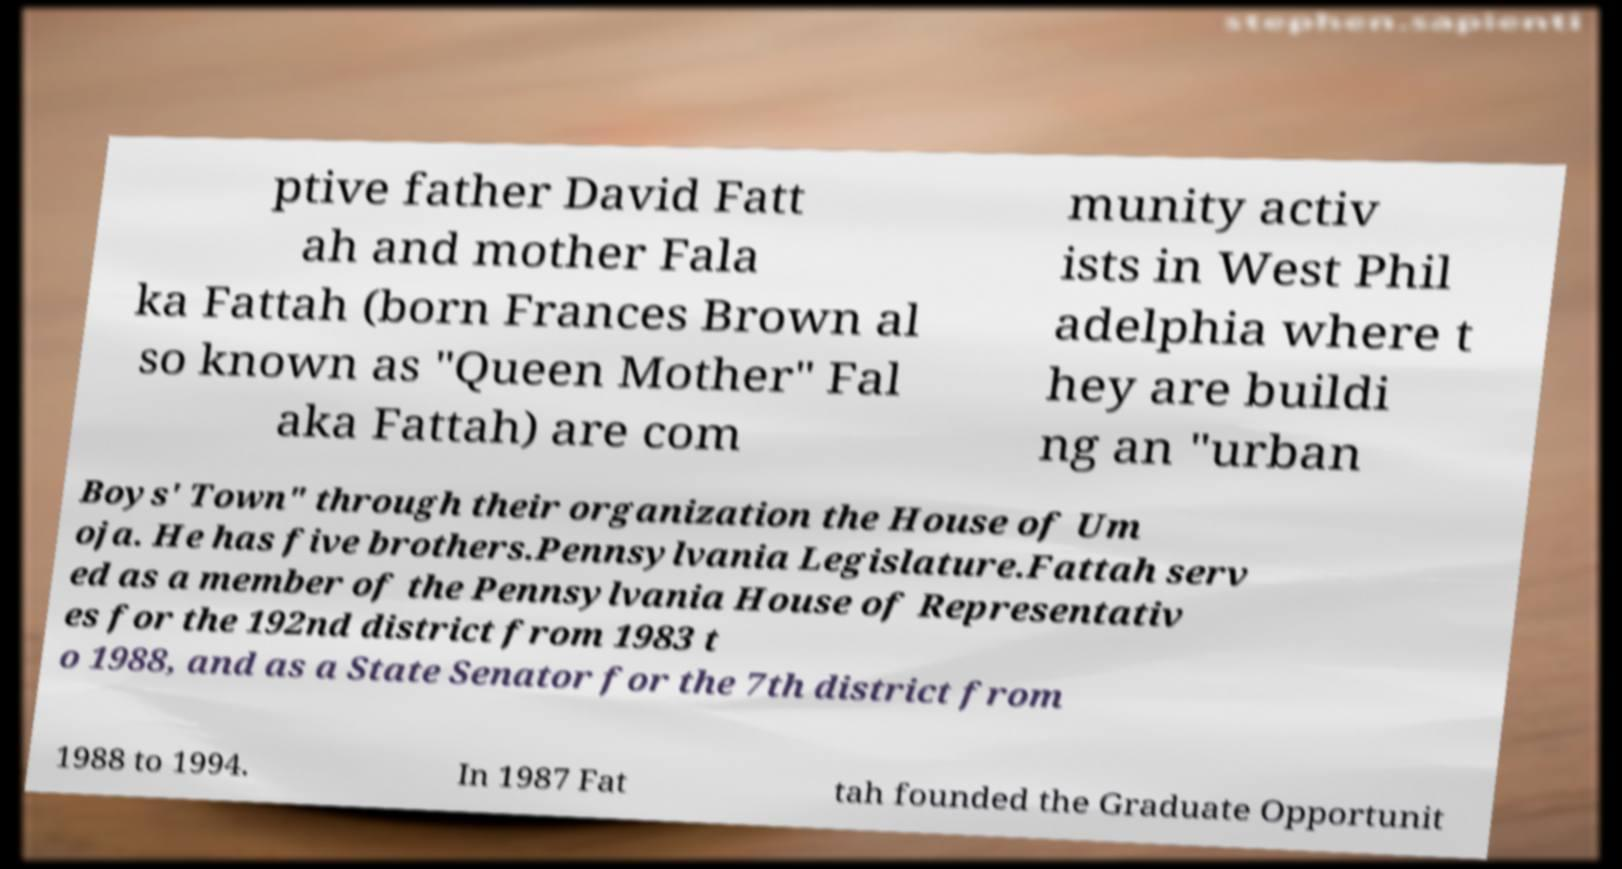Can you read and provide the text displayed in the image?This photo seems to have some interesting text. Can you extract and type it out for me? ptive father David Fatt ah and mother Fala ka Fattah (born Frances Brown al so known as "Queen Mother" Fal aka Fattah) are com munity activ ists in West Phil adelphia where t hey are buildi ng an "urban Boys' Town" through their organization the House of Um oja. He has five brothers.Pennsylvania Legislature.Fattah serv ed as a member of the Pennsylvania House of Representativ es for the 192nd district from 1983 t o 1988, and as a State Senator for the 7th district from 1988 to 1994. In 1987 Fat tah founded the Graduate Opportunit 